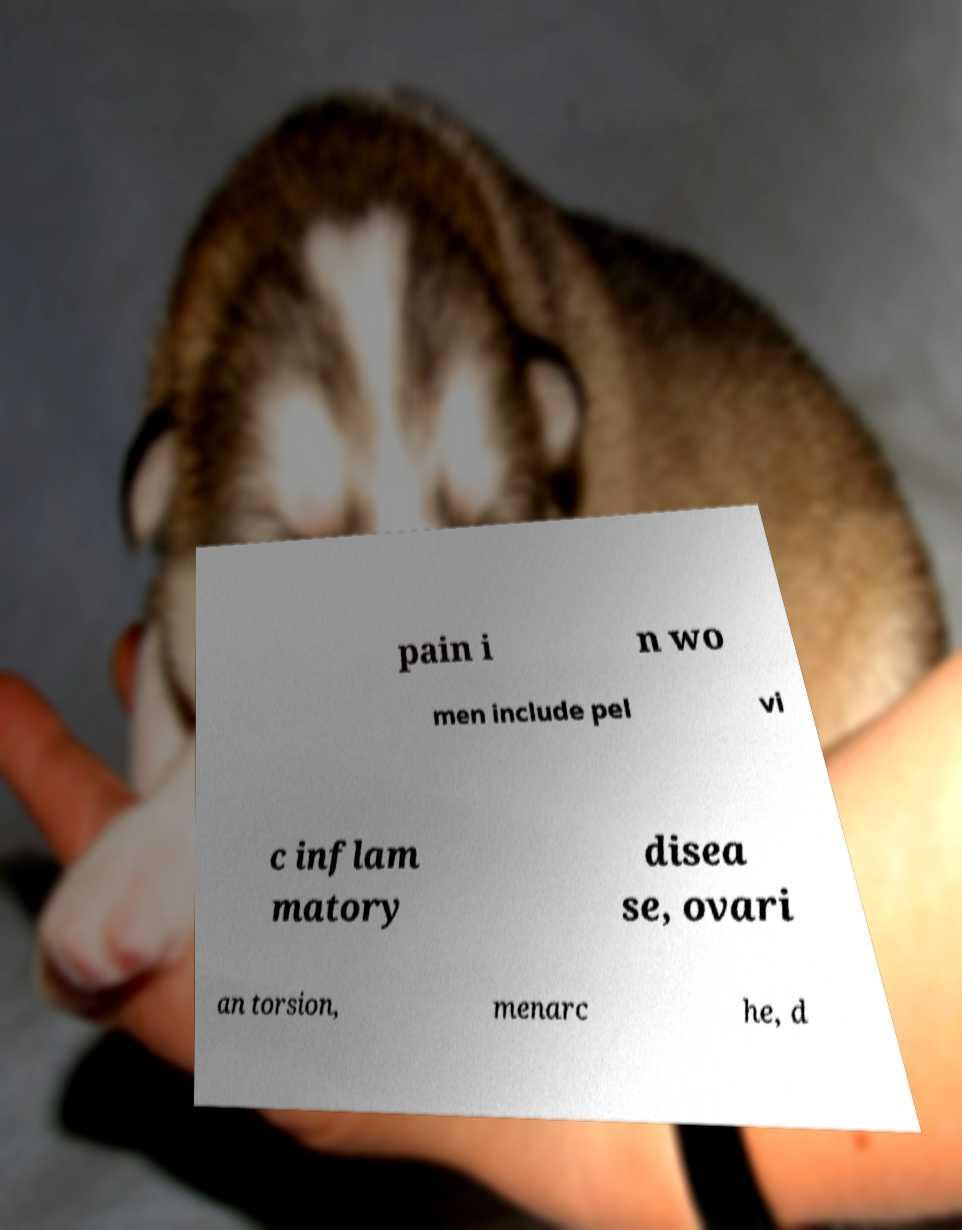Please read and relay the text visible in this image. What does it say? pain i n wo men include pel vi c inflam matory disea se, ovari an torsion, menarc he, d 